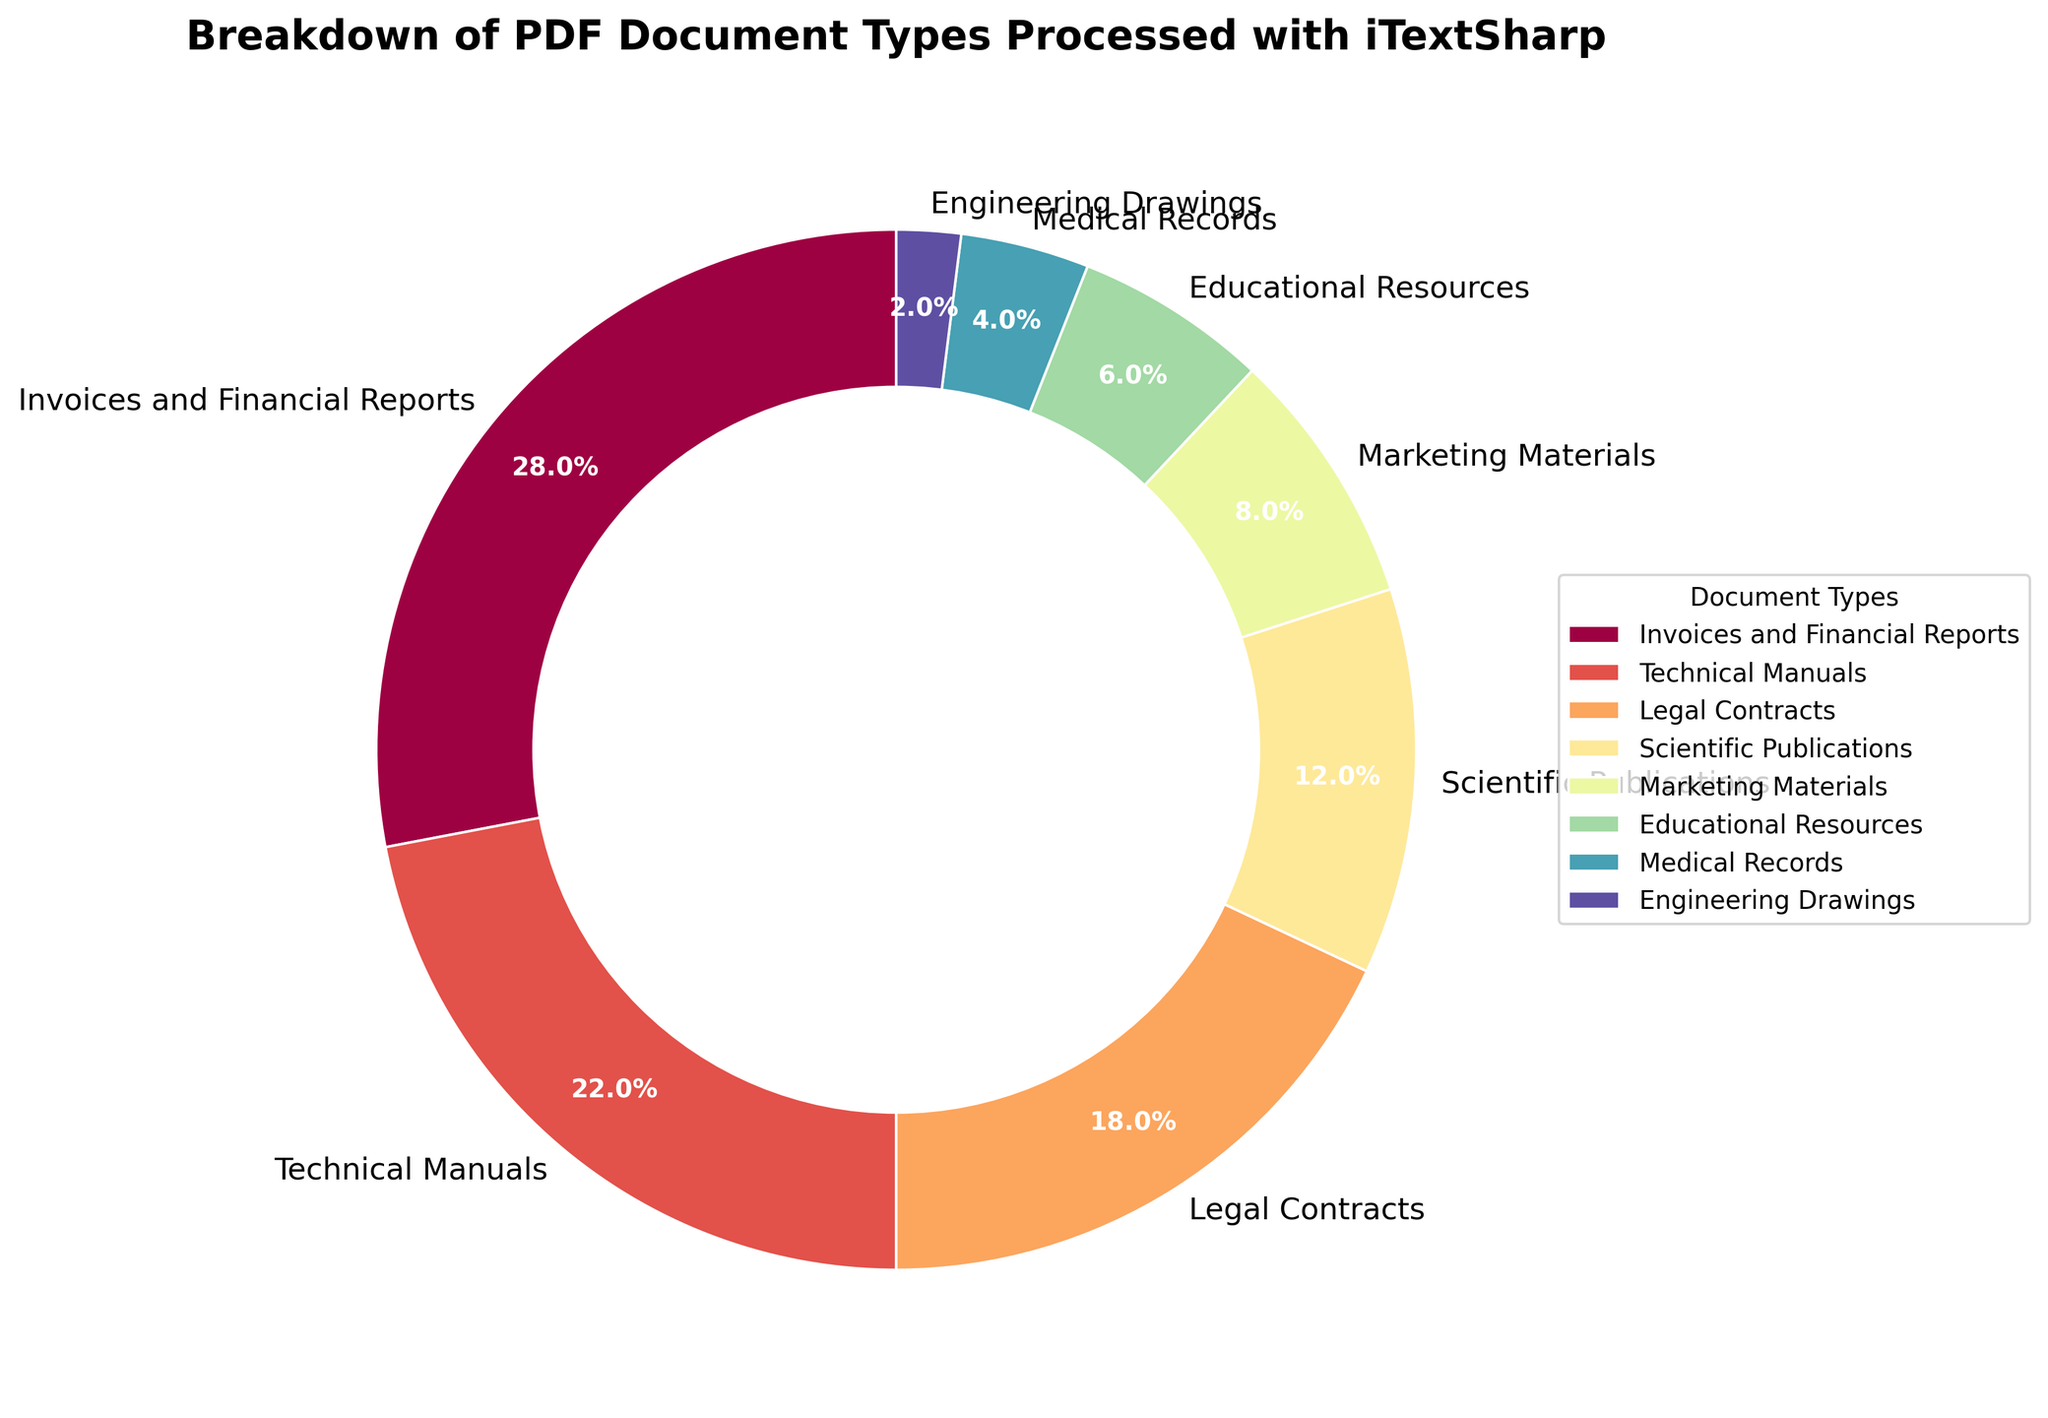Which document type represents the largest portion of the pie chart? The segment labeled "Invoices and Financial Reports" occupies the largest portion of the chart. Specifically, this segment is 28% of the entire pie, making it the largest among all document types.
Answer: Invoices and Financial Reports Which document types combined account for over half of the documents processed? To find this, we sum the percentages of document types starting from the highest. "Invoices and Financial Reports" (28%), "Technical Manuals" (22%), and "Legal Contracts" (18%) together make 68%, exceeding 50%.
Answer: Invoices and Financial Reports, Technical Manuals, Legal Contracts Which document type is just 2% of the total processed documents? The smallest segment of the pie chart, representing 2%, is labeled "Engineering Drawings."
Answer: Engineering Drawings How does the percentage of technical manuals compare to that of scientific publications? The segment for "Technical Manuals" is 22%, while "Scientific Publications" is 12%. Therefore, the percentage for technical manuals is 10% higher.
Answer: 10% higher What is the combined percentage of educational and medical resources processed? Adding the percentages of "Educational Resources" (6%) and "Medical Records" (4%), the combined percentage is 10%.
Answer: 10% Is the percentage of marketing materials greater than that of educational resources? The pie chart shows that "Marketing Materials" is 8%, which is greater than "Educational Resources" at 6%.
Answer: Yes What is the combined percentage of legal contracts and marketing materials? Adding the percentages of "Legal Contracts" (18%) and "Marketing Materials" (8%), we get a combined percentage of 26%.
Answer: 26% If the percentages of scientific publications and medical records were combined, would they surpass technical manuals? The sum of "Scientific Publications" (12%) and "Medical Records" (4%) is 16%, which is less than "Technical Manuals" at 22%.
Answer: No What is the difference in percentage between invoices/financial reports and legal contracts? The pie chart shows "Invoices and Financial Reports" at 28% and "Legal Contracts" at 18%. The difference is 28% - 18% = 10%.
Answer: 10% Which document type is displayed in the smallest segment of the pie chart? The segment that is the smallest, both visually and by percentage, is labeled "Engineering Drawings" and is 2%.
Answer: Engineering Drawings 